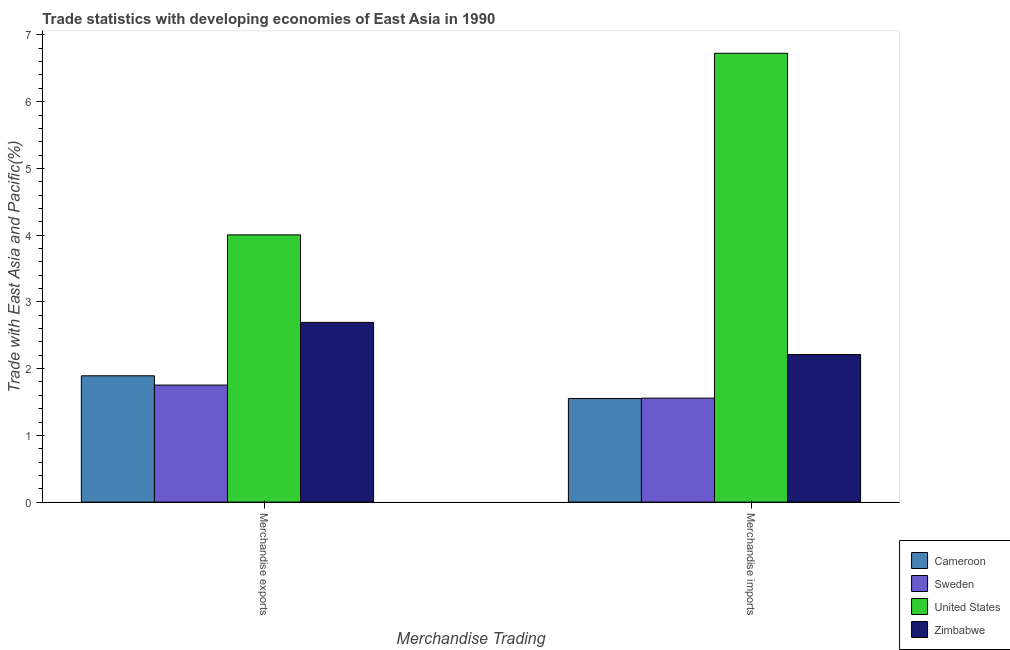How many different coloured bars are there?
Ensure brevity in your answer.  4. How many groups of bars are there?
Your answer should be very brief. 2. Are the number of bars per tick equal to the number of legend labels?
Keep it short and to the point. Yes. Are the number of bars on each tick of the X-axis equal?
Give a very brief answer. Yes. What is the merchandise exports in Zimbabwe?
Provide a succinct answer. 2.69. Across all countries, what is the maximum merchandise imports?
Your response must be concise. 6.73. Across all countries, what is the minimum merchandise exports?
Offer a terse response. 1.75. In which country was the merchandise exports minimum?
Ensure brevity in your answer.  Sweden. What is the total merchandise imports in the graph?
Ensure brevity in your answer.  12.05. What is the difference between the merchandise imports in Zimbabwe and that in Sweden?
Make the answer very short. 0.65. What is the difference between the merchandise imports in Sweden and the merchandise exports in Zimbabwe?
Make the answer very short. -1.13. What is the average merchandise exports per country?
Your answer should be compact. 2.59. What is the difference between the merchandise imports and merchandise exports in Sweden?
Make the answer very short. -0.2. In how many countries, is the merchandise exports greater than 6.4 %?
Offer a very short reply. 0. What is the ratio of the merchandise exports in United States to that in Zimbabwe?
Your answer should be compact. 1.49. Is the merchandise exports in United States less than that in Sweden?
Give a very brief answer. No. What does the 1st bar from the left in Merchandise exports represents?
Your response must be concise. Cameroon. How many bars are there?
Keep it short and to the point. 8. Are the values on the major ticks of Y-axis written in scientific E-notation?
Make the answer very short. No. Does the graph contain any zero values?
Your answer should be compact. No. Does the graph contain grids?
Make the answer very short. No. Where does the legend appear in the graph?
Make the answer very short. Bottom right. How many legend labels are there?
Ensure brevity in your answer.  4. How are the legend labels stacked?
Offer a very short reply. Vertical. What is the title of the graph?
Provide a short and direct response. Trade statistics with developing economies of East Asia in 1990. What is the label or title of the X-axis?
Offer a very short reply. Merchandise Trading. What is the label or title of the Y-axis?
Your answer should be compact. Trade with East Asia and Pacific(%). What is the Trade with East Asia and Pacific(%) in Cameroon in Merchandise exports?
Offer a terse response. 1.89. What is the Trade with East Asia and Pacific(%) of Sweden in Merchandise exports?
Your answer should be very brief. 1.75. What is the Trade with East Asia and Pacific(%) of United States in Merchandise exports?
Offer a terse response. 4. What is the Trade with East Asia and Pacific(%) in Zimbabwe in Merchandise exports?
Ensure brevity in your answer.  2.69. What is the Trade with East Asia and Pacific(%) of Cameroon in Merchandise imports?
Give a very brief answer. 1.55. What is the Trade with East Asia and Pacific(%) in Sweden in Merchandise imports?
Offer a terse response. 1.56. What is the Trade with East Asia and Pacific(%) of United States in Merchandise imports?
Make the answer very short. 6.73. What is the Trade with East Asia and Pacific(%) of Zimbabwe in Merchandise imports?
Offer a terse response. 2.21. Across all Merchandise Trading, what is the maximum Trade with East Asia and Pacific(%) of Cameroon?
Make the answer very short. 1.89. Across all Merchandise Trading, what is the maximum Trade with East Asia and Pacific(%) of Sweden?
Keep it short and to the point. 1.75. Across all Merchandise Trading, what is the maximum Trade with East Asia and Pacific(%) of United States?
Give a very brief answer. 6.73. Across all Merchandise Trading, what is the maximum Trade with East Asia and Pacific(%) in Zimbabwe?
Provide a succinct answer. 2.69. Across all Merchandise Trading, what is the minimum Trade with East Asia and Pacific(%) of Cameroon?
Your response must be concise. 1.55. Across all Merchandise Trading, what is the minimum Trade with East Asia and Pacific(%) in Sweden?
Offer a very short reply. 1.56. Across all Merchandise Trading, what is the minimum Trade with East Asia and Pacific(%) in United States?
Your answer should be compact. 4. Across all Merchandise Trading, what is the minimum Trade with East Asia and Pacific(%) in Zimbabwe?
Provide a succinct answer. 2.21. What is the total Trade with East Asia and Pacific(%) of Cameroon in the graph?
Keep it short and to the point. 3.45. What is the total Trade with East Asia and Pacific(%) in Sweden in the graph?
Keep it short and to the point. 3.31. What is the total Trade with East Asia and Pacific(%) of United States in the graph?
Offer a terse response. 10.73. What is the total Trade with East Asia and Pacific(%) of Zimbabwe in the graph?
Offer a terse response. 4.9. What is the difference between the Trade with East Asia and Pacific(%) of Cameroon in Merchandise exports and that in Merchandise imports?
Offer a very short reply. 0.34. What is the difference between the Trade with East Asia and Pacific(%) in Sweden in Merchandise exports and that in Merchandise imports?
Your answer should be very brief. 0.2. What is the difference between the Trade with East Asia and Pacific(%) of United States in Merchandise exports and that in Merchandise imports?
Offer a terse response. -2.72. What is the difference between the Trade with East Asia and Pacific(%) in Zimbabwe in Merchandise exports and that in Merchandise imports?
Your response must be concise. 0.48. What is the difference between the Trade with East Asia and Pacific(%) of Cameroon in Merchandise exports and the Trade with East Asia and Pacific(%) of Sweden in Merchandise imports?
Offer a very short reply. 0.33. What is the difference between the Trade with East Asia and Pacific(%) of Cameroon in Merchandise exports and the Trade with East Asia and Pacific(%) of United States in Merchandise imports?
Offer a terse response. -4.83. What is the difference between the Trade with East Asia and Pacific(%) of Cameroon in Merchandise exports and the Trade with East Asia and Pacific(%) of Zimbabwe in Merchandise imports?
Ensure brevity in your answer.  -0.32. What is the difference between the Trade with East Asia and Pacific(%) of Sweden in Merchandise exports and the Trade with East Asia and Pacific(%) of United States in Merchandise imports?
Ensure brevity in your answer.  -4.97. What is the difference between the Trade with East Asia and Pacific(%) in Sweden in Merchandise exports and the Trade with East Asia and Pacific(%) in Zimbabwe in Merchandise imports?
Provide a short and direct response. -0.46. What is the difference between the Trade with East Asia and Pacific(%) of United States in Merchandise exports and the Trade with East Asia and Pacific(%) of Zimbabwe in Merchandise imports?
Offer a very short reply. 1.79. What is the average Trade with East Asia and Pacific(%) in Cameroon per Merchandise Trading?
Make the answer very short. 1.72. What is the average Trade with East Asia and Pacific(%) of Sweden per Merchandise Trading?
Ensure brevity in your answer.  1.66. What is the average Trade with East Asia and Pacific(%) of United States per Merchandise Trading?
Your answer should be compact. 5.36. What is the average Trade with East Asia and Pacific(%) of Zimbabwe per Merchandise Trading?
Your answer should be compact. 2.45. What is the difference between the Trade with East Asia and Pacific(%) of Cameroon and Trade with East Asia and Pacific(%) of Sweden in Merchandise exports?
Offer a very short reply. 0.14. What is the difference between the Trade with East Asia and Pacific(%) in Cameroon and Trade with East Asia and Pacific(%) in United States in Merchandise exports?
Offer a very short reply. -2.11. What is the difference between the Trade with East Asia and Pacific(%) in Cameroon and Trade with East Asia and Pacific(%) in Zimbabwe in Merchandise exports?
Keep it short and to the point. -0.8. What is the difference between the Trade with East Asia and Pacific(%) in Sweden and Trade with East Asia and Pacific(%) in United States in Merchandise exports?
Provide a short and direct response. -2.25. What is the difference between the Trade with East Asia and Pacific(%) of Sweden and Trade with East Asia and Pacific(%) of Zimbabwe in Merchandise exports?
Give a very brief answer. -0.94. What is the difference between the Trade with East Asia and Pacific(%) in United States and Trade with East Asia and Pacific(%) in Zimbabwe in Merchandise exports?
Make the answer very short. 1.31. What is the difference between the Trade with East Asia and Pacific(%) in Cameroon and Trade with East Asia and Pacific(%) in Sweden in Merchandise imports?
Offer a very short reply. -0.01. What is the difference between the Trade with East Asia and Pacific(%) of Cameroon and Trade with East Asia and Pacific(%) of United States in Merchandise imports?
Your answer should be very brief. -5.17. What is the difference between the Trade with East Asia and Pacific(%) of Cameroon and Trade with East Asia and Pacific(%) of Zimbabwe in Merchandise imports?
Ensure brevity in your answer.  -0.66. What is the difference between the Trade with East Asia and Pacific(%) of Sweden and Trade with East Asia and Pacific(%) of United States in Merchandise imports?
Your answer should be compact. -5.17. What is the difference between the Trade with East Asia and Pacific(%) of Sweden and Trade with East Asia and Pacific(%) of Zimbabwe in Merchandise imports?
Offer a terse response. -0.65. What is the difference between the Trade with East Asia and Pacific(%) in United States and Trade with East Asia and Pacific(%) in Zimbabwe in Merchandise imports?
Provide a succinct answer. 4.51. What is the ratio of the Trade with East Asia and Pacific(%) in Cameroon in Merchandise exports to that in Merchandise imports?
Offer a very short reply. 1.22. What is the ratio of the Trade with East Asia and Pacific(%) in Sweden in Merchandise exports to that in Merchandise imports?
Offer a very short reply. 1.13. What is the ratio of the Trade with East Asia and Pacific(%) in United States in Merchandise exports to that in Merchandise imports?
Provide a short and direct response. 0.6. What is the ratio of the Trade with East Asia and Pacific(%) of Zimbabwe in Merchandise exports to that in Merchandise imports?
Provide a short and direct response. 1.22. What is the difference between the highest and the second highest Trade with East Asia and Pacific(%) in Cameroon?
Keep it short and to the point. 0.34. What is the difference between the highest and the second highest Trade with East Asia and Pacific(%) of Sweden?
Provide a succinct answer. 0.2. What is the difference between the highest and the second highest Trade with East Asia and Pacific(%) in United States?
Keep it short and to the point. 2.72. What is the difference between the highest and the second highest Trade with East Asia and Pacific(%) of Zimbabwe?
Provide a short and direct response. 0.48. What is the difference between the highest and the lowest Trade with East Asia and Pacific(%) of Cameroon?
Offer a terse response. 0.34. What is the difference between the highest and the lowest Trade with East Asia and Pacific(%) in Sweden?
Ensure brevity in your answer.  0.2. What is the difference between the highest and the lowest Trade with East Asia and Pacific(%) of United States?
Offer a very short reply. 2.72. What is the difference between the highest and the lowest Trade with East Asia and Pacific(%) in Zimbabwe?
Your answer should be very brief. 0.48. 